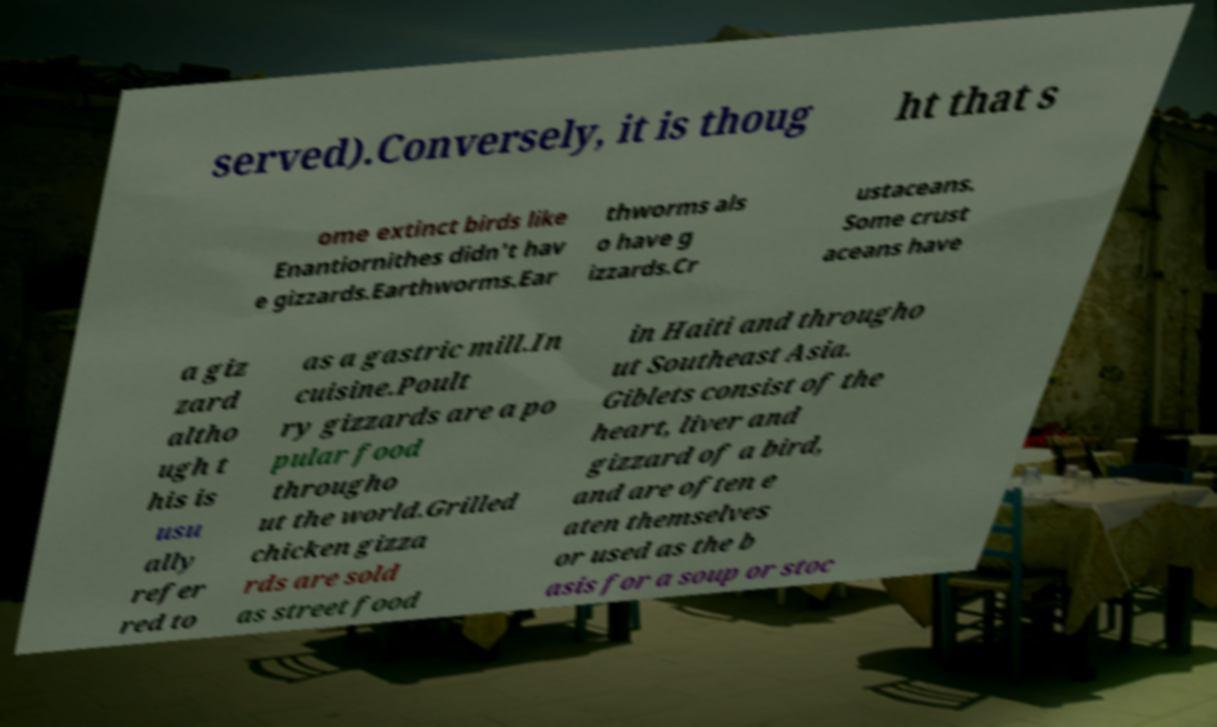Could you assist in decoding the text presented in this image and type it out clearly? served).Conversely, it is thoug ht that s ome extinct birds like Enantiornithes didn't hav e gizzards.Earthworms.Ear thworms als o have g izzards.Cr ustaceans. Some crust aceans have a giz zard altho ugh t his is usu ally refer red to as a gastric mill.In cuisine.Poult ry gizzards are a po pular food througho ut the world.Grilled chicken gizza rds are sold as street food in Haiti and througho ut Southeast Asia. Giblets consist of the heart, liver and gizzard of a bird, and are often e aten themselves or used as the b asis for a soup or stoc 